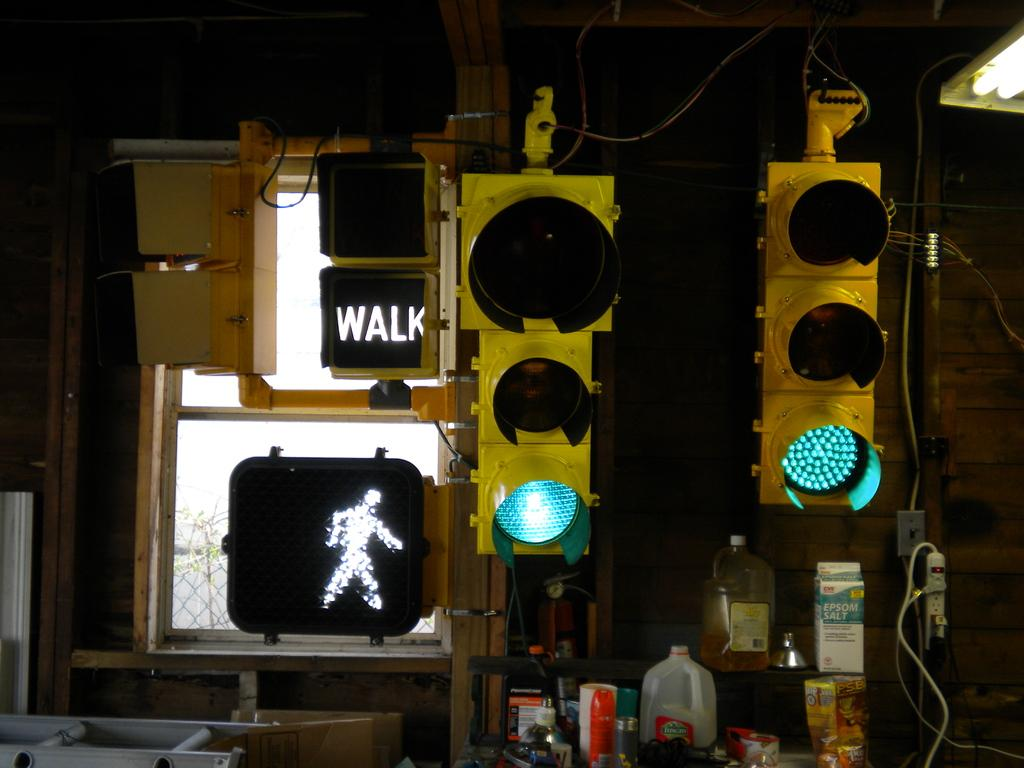<image>
Share a concise interpretation of the image provided. the word walk is on the sign next to the light 